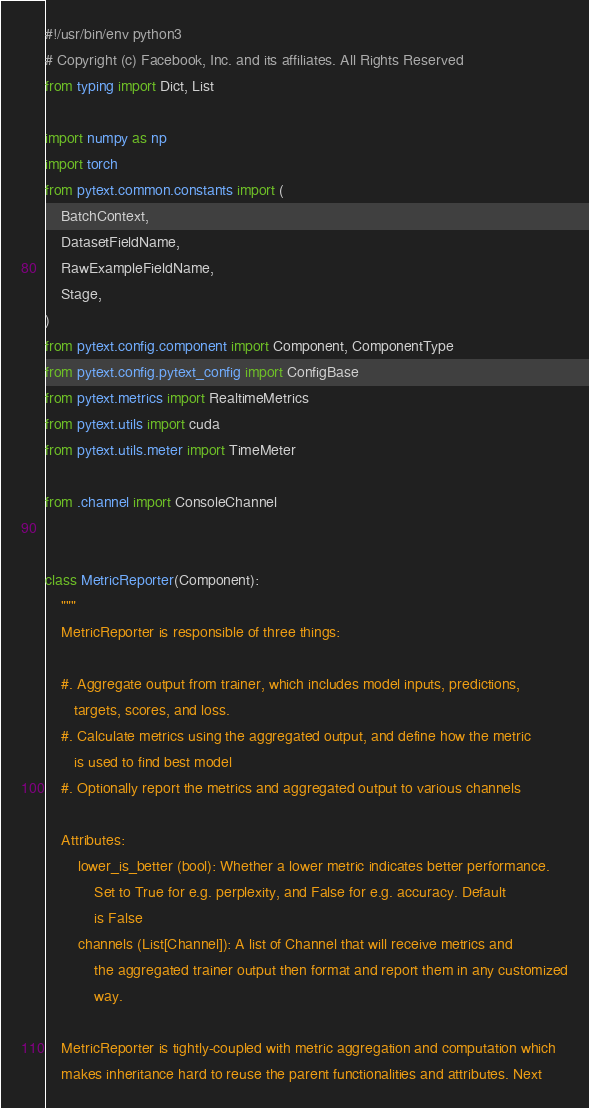<code> <loc_0><loc_0><loc_500><loc_500><_Python_>#!/usr/bin/env python3
# Copyright (c) Facebook, Inc. and its affiliates. All Rights Reserved
from typing import Dict, List

import numpy as np
import torch
from pytext.common.constants import (
    BatchContext,
    DatasetFieldName,
    RawExampleFieldName,
    Stage,
)
from pytext.config.component import Component, ComponentType
from pytext.config.pytext_config import ConfigBase
from pytext.metrics import RealtimeMetrics
from pytext.utils import cuda
from pytext.utils.meter import TimeMeter

from .channel import ConsoleChannel


class MetricReporter(Component):
    """
    MetricReporter is responsible of three things:

    #. Aggregate output from trainer, which includes model inputs, predictions,
       targets, scores, and loss.
    #. Calculate metrics using the aggregated output, and define how the metric
       is used to find best model
    #. Optionally report the metrics and aggregated output to various channels

    Attributes:
        lower_is_better (bool): Whether a lower metric indicates better performance.
            Set to True for e.g. perplexity, and False for e.g. accuracy. Default
            is False
        channels (List[Channel]): A list of Channel that will receive metrics and
            the aggregated trainer output then format and report them in any customized
            way.

    MetricReporter is tightly-coupled with metric aggregation and computation which
    makes inheritance hard to reuse the parent functionalities and attributes. Next</code> 